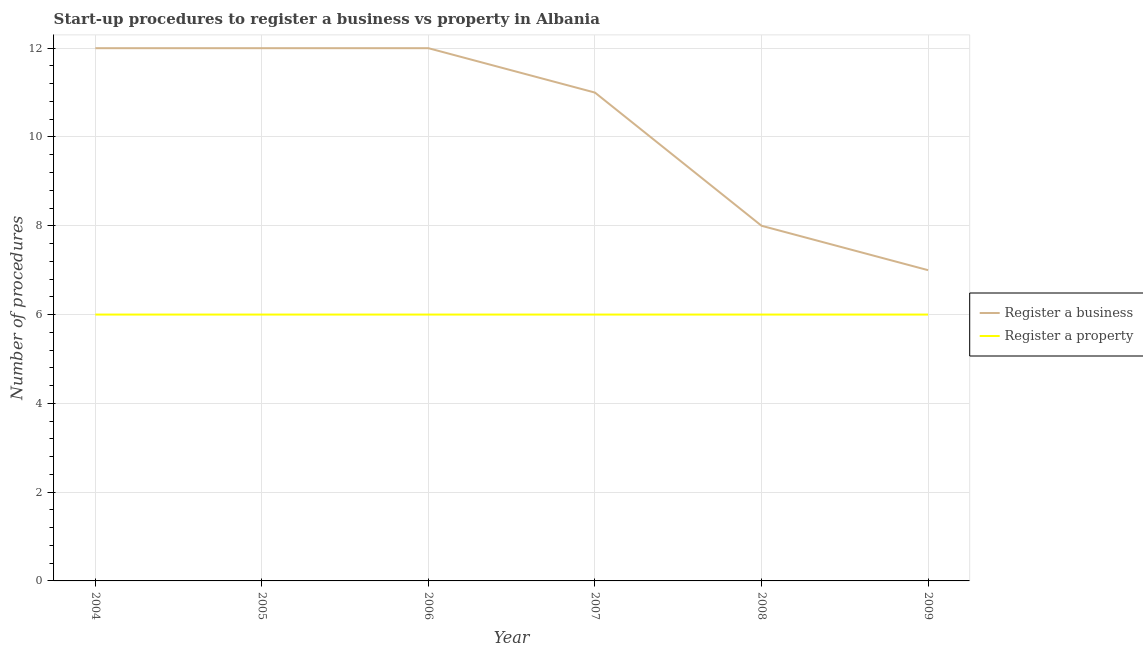Does the line corresponding to number of procedures to register a property intersect with the line corresponding to number of procedures to register a business?
Your answer should be very brief. No. What is the number of procedures to register a business in 2005?
Your answer should be compact. 12. Across all years, what is the maximum number of procedures to register a business?
Your answer should be compact. 12. In which year was the number of procedures to register a business maximum?
Provide a succinct answer. 2004. In which year was the number of procedures to register a business minimum?
Provide a succinct answer. 2009. What is the total number of procedures to register a property in the graph?
Provide a short and direct response. 36. What is the difference between the number of procedures to register a business in 2004 and that in 2006?
Keep it short and to the point. 0. What is the difference between the number of procedures to register a property in 2008 and the number of procedures to register a business in 2007?
Ensure brevity in your answer.  -5. In the year 2007, what is the difference between the number of procedures to register a business and number of procedures to register a property?
Your answer should be very brief. 5. In how many years, is the number of procedures to register a property greater than 11.2?
Your answer should be compact. 0. What is the ratio of the number of procedures to register a business in 2006 to that in 2007?
Provide a succinct answer. 1.09. Is the number of procedures to register a property in 2004 less than that in 2007?
Your answer should be compact. No. What is the difference between the highest and the lowest number of procedures to register a business?
Provide a short and direct response. 5. In how many years, is the number of procedures to register a property greater than the average number of procedures to register a property taken over all years?
Offer a terse response. 0. Does the number of procedures to register a property monotonically increase over the years?
Your answer should be compact. No. Is the number of procedures to register a business strictly greater than the number of procedures to register a property over the years?
Your response must be concise. Yes. How many lines are there?
Your answer should be very brief. 2. What is the difference between two consecutive major ticks on the Y-axis?
Make the answer very short. 2. Are the values on the major ticks of Y-axis written in scientific E-notation?
Make the answer very short. No. Does the graph contain grids?
Offer a very short reply. Yes. Where does the legend appear in the graph?
Provide a short and direct response. Center right. What is the title of the graph?
Provide a succinct answer. Start-up procedures to register a business vs property in Albania. Does "Current US$" appear as one of the legend labels in the graph?
Make the answer very short. No. What is the label or title of the Y-axis?
Give a very brief answer. Number of procedures. What is the Number of procedures of Register a business in 2004?
Provide a succinct answer. 12. What is the Number of procedures in Register a business in 2006?
Give a very brief answer. 12. What is the Number of procedures of Register a property in 2007?
Your response must be concise. 6. What is the Number of procedures in Register a business in 2008?
Your response must be concise. 8. Across all years, what is the maximum Number of procedures of Register a business?
Make the answer very short. 12. Across all years, what is the maximum Number of procedures in Register a property?
Provide a short and direct response. 6. Across all years, what is the minimum Number of procedures of Register a business?
Provide a short and direct response. 7. What is the difference between the Number of procedures in Register a business in 2004 and that in 2005?
Your response must be concise. 0. What is the difference between the Number of procedures of Register a property in 2004 and that in 2005?
Your response must be concise. 0. What is the difference between the Number of procedures in Register a property in 2004 and that in 2006?
Keep it short and to the point. 0. What is the difference between the Number of procedures of Register a property in 2004 and that in 2007?
Provide a succinct answer. 0. What is the difference between the Number of procedures of Register a business in 2004 and that in 2008?
Your response must be concise. 4. What is the difference between the Number of procedures of Register a business in 2004 and that in 2009?
Ensure brevity in your answer.  5. What is the difference between the Number of procedures of Register a business in 2005 and that in 2006?
Provide a short and direct response. 0. What is the difference between the Number of procedures of Register a business in 2005 and that in 2007?
Provide a succinct answer. 1. What is the difference between the Number of procedures in Register a business in 2005 and that in 2008?
Make the answer very short. 4. What is the difference between the Number of procedures in Register a property in 2005 and that in 2008?
Offer a very short reply. 0. What is the difference between the Number of procedures in Register a property in 2005 and that in 2009?
Give a very brief answer. 0. What is the difference between the Number of procedures of Register a business in 2006 and that in 2007?
Offer a very short reply. 1. What is the difference between the Number of procedures in Register a business in 2006 and that in 2008?
Give a very brief answer. 4. What is the difference between the Number of procedures of Register a property in 2006 and that in 2009?
Ensure brevity in your answer.  0. What is the difference between the Number of procedures in Register a business in 2007 and that in 2008?
Your answer should be compact. 3. What is the difference between the Number of procedures in Register a business in 2007 and that in 2009?
Your answer should be compact. 4. What is the difference between the Number of procedures of Register a property in 2007 and that in 2009?
Your response must be concise. 0. What is the difference between the Number of procedures in Register a business in 2008 and that in 2009?
Keep it short and to the point. 1. What is the difference between the Number of procedures in Register a business in 2004 and the Number of procedures in Register a property in 2005?
Ensure brevity in your answer.  6. What is the difference between the Number of procedures of Register a business in 2004 and the Number of procedures of Register a property in 2007?
Keep it short and to the point. 6. What is the difference between the Number of procedures of Register a business in 2004 and the Number of procedures of Register a property in 2008?
Keep it short and to the point. 6. What is the difference between the Number of procedures of Register a business in 2005 and the Number of procedures of Register a property in 2006?
Make the answer very short. 6. What is the difference between the Number of procedures in Register a business in 2006 and the Number of procedures in Register a property in 2007?
Your answer should be very brief. 6. What is the difference between the Number of procedures of Register a business in 2006 and the Number of procedures of Register a property in 2008?
Keep it short and to the point. 6. What is the difference between the Number of procedures in Register a business in 2007 and the Number of procedures in Register a property in 2008?
Your answer should be very brief. 5. What is the difference between the Number of procedures of Register a business in 2008 and the Number of procedures of Register a property in 2009?
Provide a short and direct response. 2. What is the average Number of procedures of Register a business per year?
Offer a terse response. 10.33. What is the average Number of procedures in Register a property per year?
Give a very brief answer. 6. In the year 2004, what is the difference between the Number of procedures in Register a business and Number of procedures in Register a property?
Offer a terse response. 6. In the year 2005, what is the difference between the Number of procedures of Register a business and Number of procedures of Register a property?
Offer a terse response. 6. In the year 2006, what is the difference between the Number of procedures in Register a business and Number of procedures in Register a property?
Offer a terse response. 6. What is the ratio of the Number of procedures in Register a business in 2004 to that in 2005?
Provide a succinct answer. 1. What is the ratio of the Number of procedures of Register a business in 2004 to that in 2006?
Provide a succinct answer. 1. What is the ratio of the Number of procedures of Register a business in 2004 to that in 2007?
Keep it short and to the point. 1.09. What is the ratio of the Number of procedures of Register a property in 2004 to that in 2007?
Your answer should be compact. 1. What is the ratio of the Number of procedures in Register a business in 2004 to that in 2008?
Keep it short and to the point. 1.5. What is the ratio of the Number of procedures of Register a property in 2004 to that in 2008?
Offer a very short reply. 1. What is the ratio of the Number of procedures in Register a business in 2004 to that in 2009?
Your response must be concise. 1.71. What is the ratio of the Number of procedures of Register a property in 2004 to that in 2009?
Provide a short and direct response. 1. What is the ratio of the Number of procedures in Register a business in 2005 to that in 2006?
Keep it short and to the point. 1. What is the ratio of the Number of procedures in Register a business in 2005 to that in 2007?
Provide a succinct answer. 1.09. What is the ratio of the Number of procedures in Register a property in 2005 to that in 2008?
Provide a succinct answer. 1. What is the ratio of the Number of procedures of Register a business in 2005 to that in 2009?
Your answer should be compact. 1.71. What is the ratio of the Number of procedures in Register a property in 2005 to that in 2009?
Your answer should be compact. 1. What is the ratio of the Number of procedures of Register a business in 2006 to that in 2008?
Provide a short and direct response. 1.5. What is the ratio of the Number of procedures of Register a property in 2006 to that in 2008?
Offer a terse response. 1. What is the ratio of the Number of procedures of Register a business in 2006 to that in 2009?
Your answer should be compact. 1.71. What is the ratio of the Number of procedures of Register a business in 2007 to that in 2008?
Give a very brief answer. 1.38. What is the ratio of the Number of procedures of Register a business in 2007 to that in 2009?
Provide a short and direct response. 1.57. What is the ratio of the Number of procedures in Register a property in 2007 to that in 2009?
Ensure brevity in your answer.  1. What is the ratio of the Number of procedures in Register a property in 2008 to that in 2009?
Your answer should be compact. 1. What is the difference between the highest and the second highest Number of procedures of Register a business?
Make the answer very short. 0. What is the difference between the highest and the second highest Number of procedures of Register a property?
Keep it short and to the point. 0. 